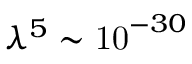<formula> <loc_0><loc_0><loc_500><loc_500>\lambda ^ { 5 } \sim { 1 0 } ^ { - 3 0 }</formula> 